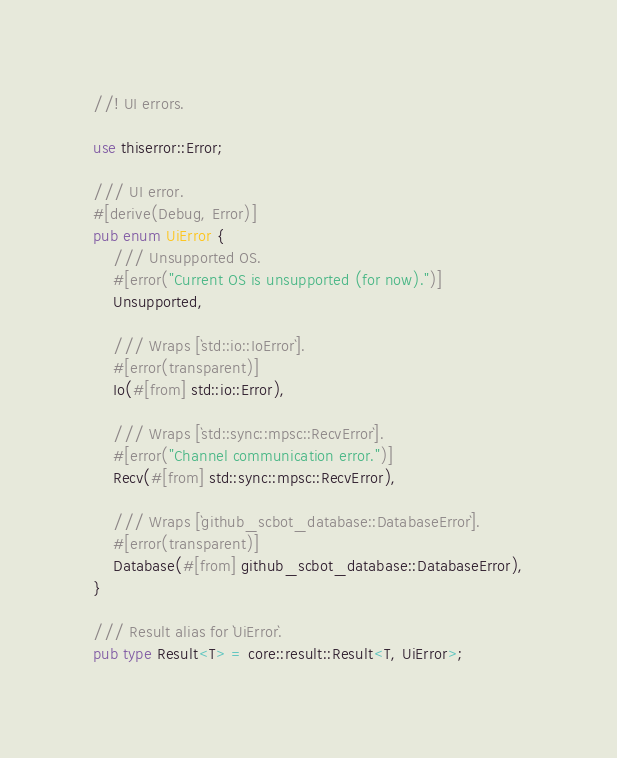Convert code to text. <code><loc_0><loc_0><loc_500><loc_500><_Rust_>//! UI errors.

use thiserror::Error;

/// UI error.
#[derive(Debug, Error)]
pub enum UiError {
    /// Unsupported OS.
    #[error("Current OS is unsupported (for now).")]
    Unsupported,

    /// Wraps [`std::io::IoError`].
    #[error(transparent)]
    Io(#[from] std::io::Error),

    /// Wraps [`std::sync::mpsc::RecvError`].
    #[error("Channel communication error.")]
    Recv(#[from] std::sync::mpsc::RecvError),

    /// Wraps [`github_scbot_database::DatabaseError`].
    #[error(transparent)]
    Database(#[from] github_scbot_database::DatabaseError),
}

/// Result alias for `UiError`.
pub type Result<T> = core::result::Result<T, UiError>;
</code> 